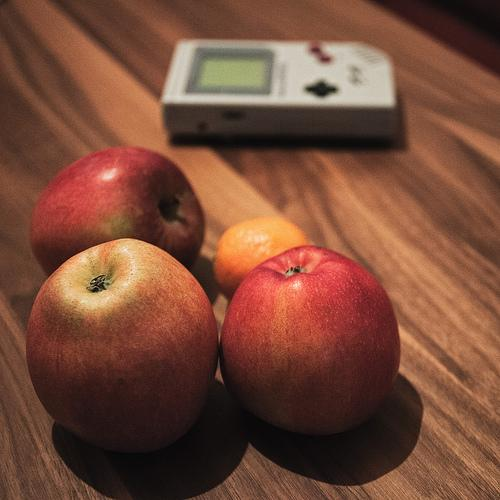Describe the color and texture of the table. The table is brown with a wood grain texture How many buttons are visible on the gaming device and mention their colors? There are two visible buttons on the gaming device, one is red and the other is black. What does the tangerine resemble? The tangerine looks like a Cutie. Count the number of apples in the image. There are three apples in the image. What fruit is placed alongside the apples on the table? An orange is placed alongside the apples on the table. Explain the positioning of the three apples. One apple is hiding part of the tangerine while the other two apples are facing up with their bottom ends visible. Identify the type of gaming device in the background. An old style Game Boy is in the background. How many fruits are there in total on the table? There are four fruits in total on the table. Mention the color of the fruit that is not an apple. The fruit, which is an orange, has an orange color. Describe the lighting conditions in the room. The room is well lit. How many apples are there in the image? Three What is the scene of the image? Fruits on a table with a Gameboy in the background, in an indoor and well-lit room. A slice of pizza rests on the table, competing for attention with the fruits. No, it's not mentioned in the image. What do the objects in the image represent? Fruits and a gaming device placed on a wood grain table, casting shadows and creating an indoor scene. Describe the button colors on the gaming device in the image. Red and black What type of table surface is present in the image? Brown and tan wood grain Based on the image, how is the apple tilted? Tilted to the side Describe the gaming device on the table. An old-style Gameboy with a window on top, black and red buttons on the surface, and functional portals on the side. It is out of focus in the image. What fruit is hiding part of the tangerine in the image? Apple In the image, is the room well lit or poorly lit? Well lit Describe the contrast between the apples and the tangerine in the image. The apples are yellow and red, while the tangerine is orange. What kind of shadows are visible on the table in the image? Shadows of apples How does the tangerine in the image appear? It looks like a cutie. Identify the text on the device in the image. No text is present. What is happening in the image with the fruits on the table? Fruits are placed on the table, casting shadows, and an apple is hiding part of the tangerine. In the image, what orientation are the bottoms of the apples in relation to the table? Bottoms facing up Create a short story based on the image. Once upon a time, in a well-lit room, an old-style Gameboy guarded three apples and a tangerine on a wooden table. The apples cast shadows as they tilted to one side, while the tangerine remained in the background, trying to blend in. What color is the table in the image? Brown Is there any diagram present in the image? No Which fruits are on the table in the image? Apples and a tangerine 